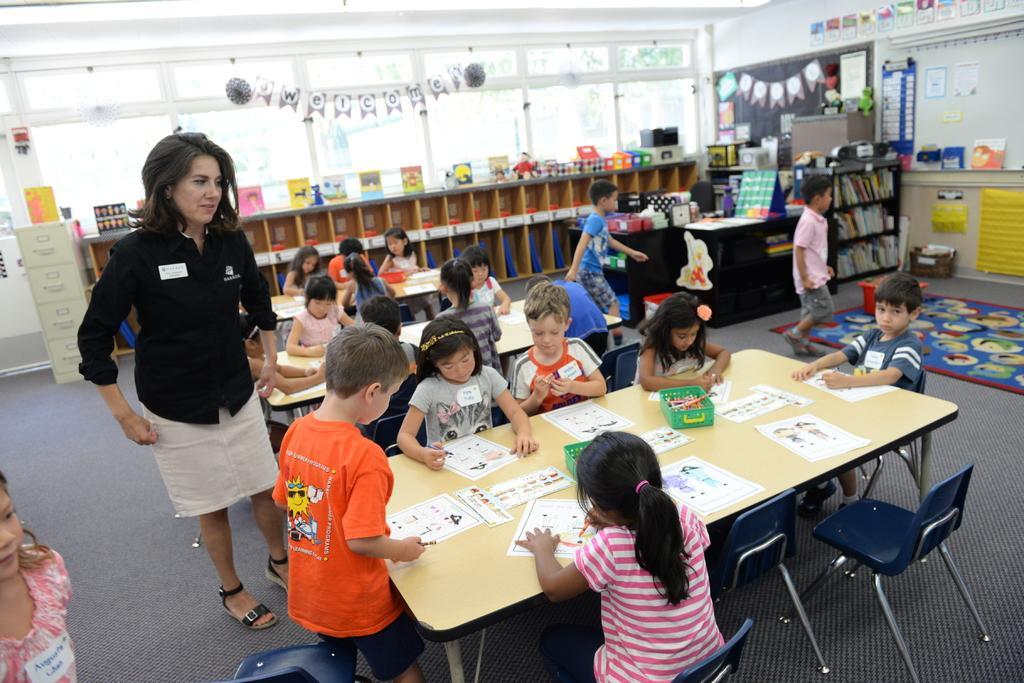Can you describe this image briefly? In the picture we can see some children are sitting on a chair near the tables, on the table we can find a papers, a paintings, and drawings and one woman standing near to the table wearing a black shirt with the slippers on the floor. In the background we can find some racks, books, tables, and on tables we can find something papers, colored papers, board and something is pasted on it. 